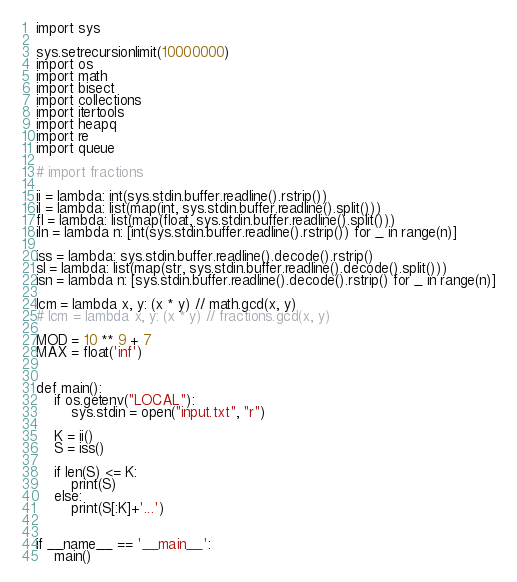<code> <loc_0><loc_0><loc_500><loc_500><_Python_>import sys

sys.setrecursionlimit(10000000)
import os
import math
import bisect
import collections
import itertools
import heapq
import re
import queue

# import fractions

ii = lambda: int(sys.stdin.buffer.readline().rstrip())
il = lambda: list(map(int, sys.stdin.buffer.readline().split()))
fl = lambda: list(map(float, sys.stdin.buffer.readline().split()))
iln = lambda n: [int(sys.stdin.buffer.readline().rstrip()) for _ in range(n)]

iss = lambda: sys.stdin.buffer.readline().decode().rstrip()
sl = lambda: list(map(str, sys.stdin.buffer.readline().decode().split()))
isn = lambda n: [sys.stdin.buffer.readline().decode().rstrip() for _ in range(n)]

lcm = lambda x, y: (x * y) // math.gcd(x, y)
# lcm = lambda x, y: (x * y) // fractions.gcd(x, y)

MOD = 10 ** 9 + 7
MAX = float('inf')


def main():
    if os.getenv("LOCAL"):
        sys.stdin = open("input.txt", "r")

    K = ii()
    S = iss()

    if len(S) <= K:
        print(S)
    else:
        print(S[:K]+'...')


if __name__ == '__main__':
    main()
</code> 